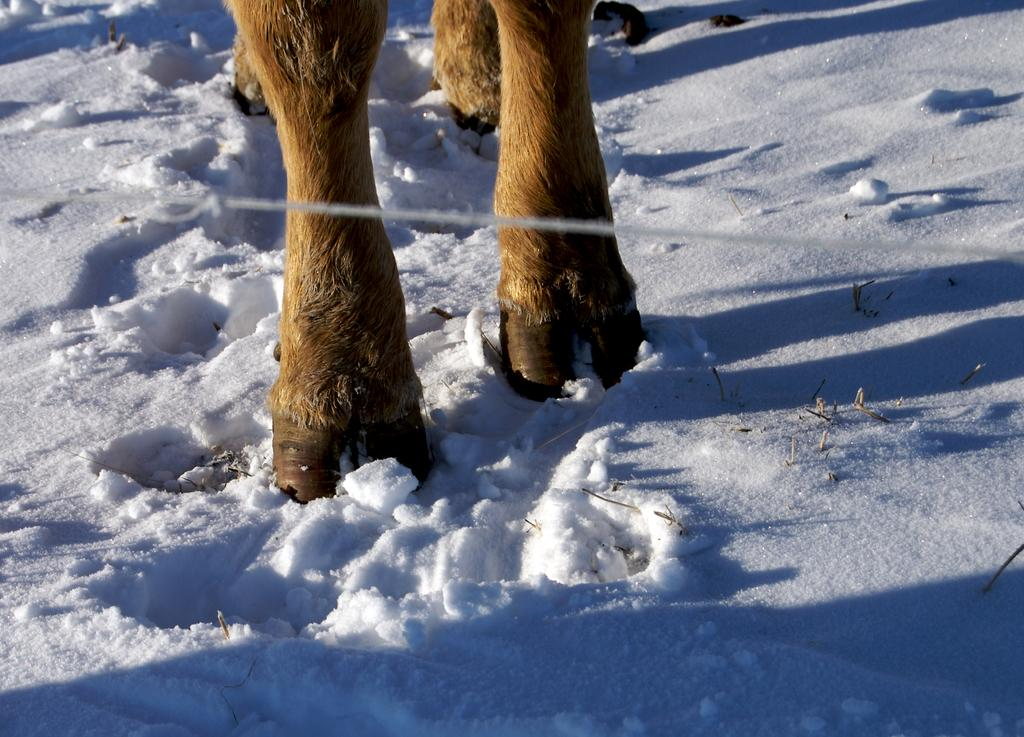What type of legs are visible in the image? Animal legs are visible in the image. What is the background setting in the image? There is snow visible in the background of the image. What time of day is it in the image, considering the presence of morning light? There is no indication of morning light or any specific time of day in the image. What type of current can be seen flowing through the image? There is no current visible in the image; it features animal legs and snow. 